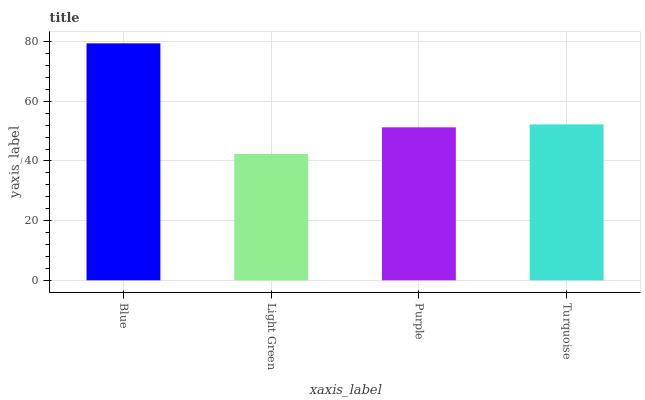Is Light Green the minimum?
Answer yes or no. Yes. Is Blue the maximum?
Answer yes or no. Yes. Is Purple the minimum?
Answer yes or no. No. Is Purple the maximum?
Answer yes or no. No. Is Purple greater than Light Green?
Answer yes or no. Yes. Is Light Green less than Purple?
Answer yes or no. Yes. Is Light Green greater than Purple?
Answer yes or no. No. Is Purple less than Light Green?
Answer yes or no. No. Is Turquoise the high median?
Answer yes or no. Yes. Is Purple the low median?
Answer yes or no. Yes. Is Light Green the high median?
Answer yes or no. No. Is Light Green the low median?
Answer yes or no. No. 